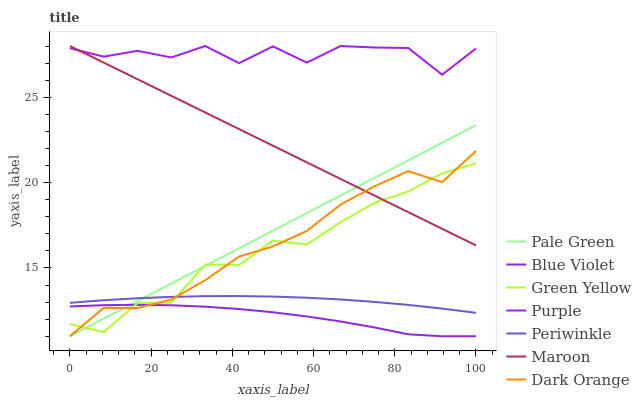Does Maroon have the minimum area under the curve?
Answer yes or no. No. Does Maroon have the maximum area under the curve?
Answer yes or no. No. Is Maroon the smoothest?
Answer yes or no. No. Is Maroon the roughest?
Answer yes or no. No. Does Maroon have the lowest value?
Answer yes or no. No. Does Pale Green have the highest value?
Answer yes or no. No. Is Blue Violet less than Purple?
Answer yes or no. Yes. Is Maroon greater than Blue Violet?
Answer yes or no. Yes. Does Blue Violet intersect Purple?
Answer yes or no. No. 